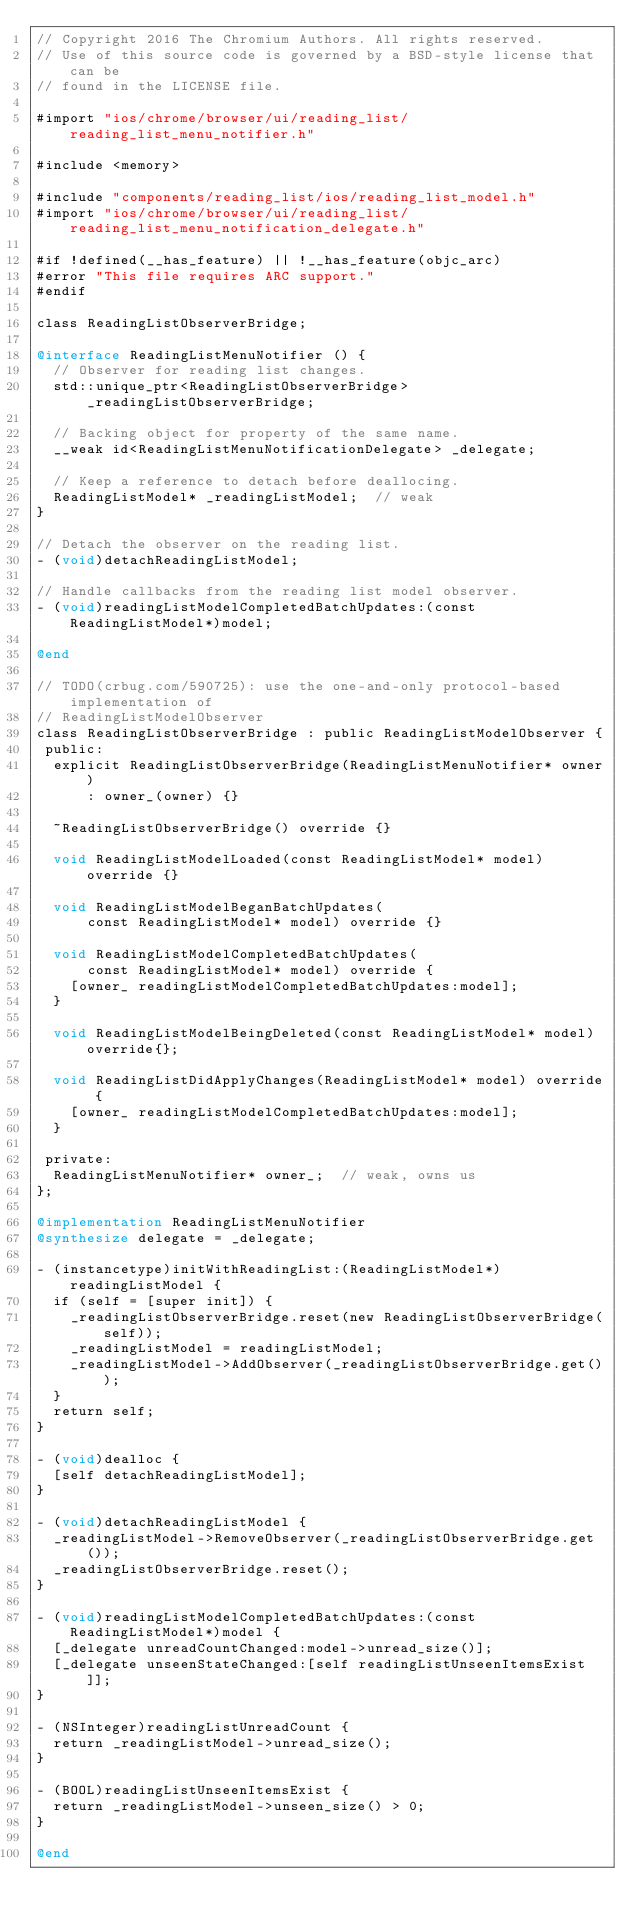<code> <loc_0><loc_0><loc_500><loc_500><_ObjectiveC_>// Copyright 2016 The Chromium Authors. All rights reserved.
// Use of this source code is governed by a BSD-style license that can be
// found in the LICENSE file.

#import "ios/chrome/browser/ui/reading_list/reading_list_menu_notifier.h"

#include <memory>

#include "components/reading_list/ios/reading_list_model.h"
#import "ios/chrome/browser/ui/reading_list/reading_list_menu_notification_delegate.h"

#if !defined(__has_feature) || !__has_feature(objc_arc)
#error "This file requires ARC support."
#endif

class ReadingListObserverBridge;

@interface ReadingListMenuNotifier () {
  // Observer for reading list changes.
  std::unique_ptr<ReadingListObserverBridge> _readingListObserverBridge;

  // Backing object for property of the same name.
  __weak id<ReadingListMenuNotificationDelegate> _delegate;

  // Keep a reference to detach before deallocing.
  ReadingListModel* _readingListModel;  // weak
}

// Detach the observer on the reading list.
- (void)detachReadingListModel;

// Handle callbacks from the reading list model observer.
- (void)readingListModelCompletedBatchUpdates:(const ReadingListModel*)model;

@end

// TODO(crbug.com/590725): use the one-and-only protocol-based implementation of
// ReadingListModelObserver
class ReadingListObserverBridge : public ReadingListModelObserver {
 public:
  explicit ReadingListObserverBridge(ReadingListMenuNotifier* owner)
      : owner_(owner) {}

  ~ReadingListObserverBridge() override {}

  void ReadingListModelLoaded(const ReadingListModel* model) override {}

  void ReadingListModelBeganBatchUpdates(
      const ReadingListModel* model) override {}

  void ReadingListModelCompletedBatchUpdates(
      const ReadingListModel* model) override {
    [owner_ readingListModelCompletedBatchUpdates:model];
  }

  void ReadingListModelBeingDeleted(const ReadingListModel* model) override{};

  void ReadingListDidApplyChanges(ReadingListModel* model) override {
    [owner_ readingListModelCompletedBatchUpdates:model];
  }

 private:
  ReadingListMenuNotifier* owner_;  // weak, owns us
};

@implementation ReadingListMenuNotifier
@synthesize delegate = _delegate;

- (instancetype)initWithReadingList:(ReadingListModel*)readingListModel {
  if (self = [super init]) {
    _readingListObserverBridge.reset(new ReadingListObserverBridge(self));
    _readingListModel = readingListModel;
    _readingListModel->AddObserver(_readingListObserverBridge.get());
  }
  return self;
}

- (void)dealloc {
  [self detachReadingListModel];
}

- (void)detachReadingListModel {
  _readingListModel->RemoveObserver(_readingListObserverBridge.get());
  _readingListObserverBridge.reset();
}

- (void)readingListModelCompletedBatchUpdates:(const ReadingListModel*)model {
  [_delegate unreadCountChanged:model->unread_size()];
  [_delegate unseenStateChanged:[self readingListUnseenItemsExist]];
}

- (NSInteger)readingListUnreadCount {
  return _readingListModel->unread_size();
}

- (BOOL)readingListUnseenItemsExist {
  return _readingListModel->unseen_size() > 0;
}

@end
</code> 